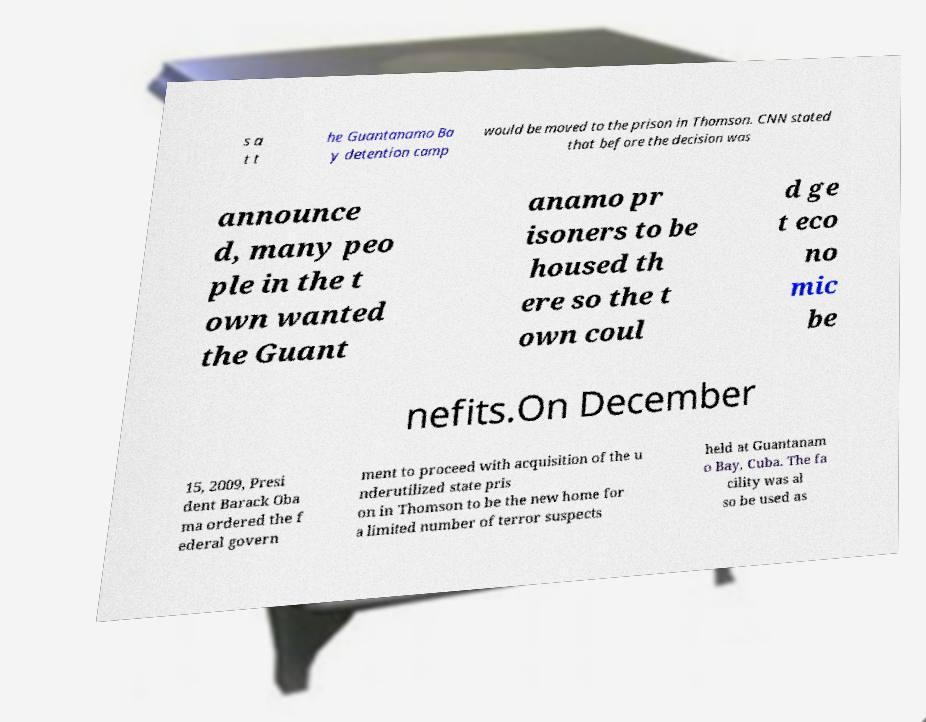What messages or text are displayed in this image? I need them in a readable, typed format. s a t t he Guantanamo Ba y detention camp would be moved to the prison in Thomson. CNN stated that before the decision was announce d, many peo ple in the t own wanted the Guant anamo pr isoners to be housed th ere so the t own coul d ge t eco no mic be nefits.On December 15, 2009, Presi dent Barack Oba ma ordered the f ederal govern ment to proceed with acquisition of the u nderutilized state pris on in Thomson to be the new home for a limited number of terror suspects held at Guantanam o Bay, Cuba. The fa cility was al so be used as 